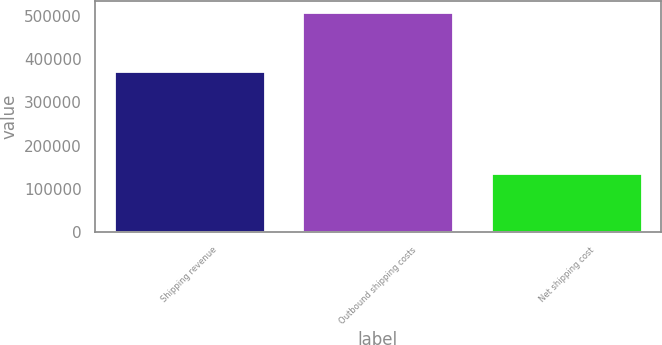Convert chart to OTSL. <chart><loc_0><loc_0><loc_500><loc_500><bar_chart><fcel>Shipping revenue<fcel>Outbound shipping costs<fcel>Net shipping cost<nl><fcel>372000<fcel>508468<fcel>136468<nl></chart> 